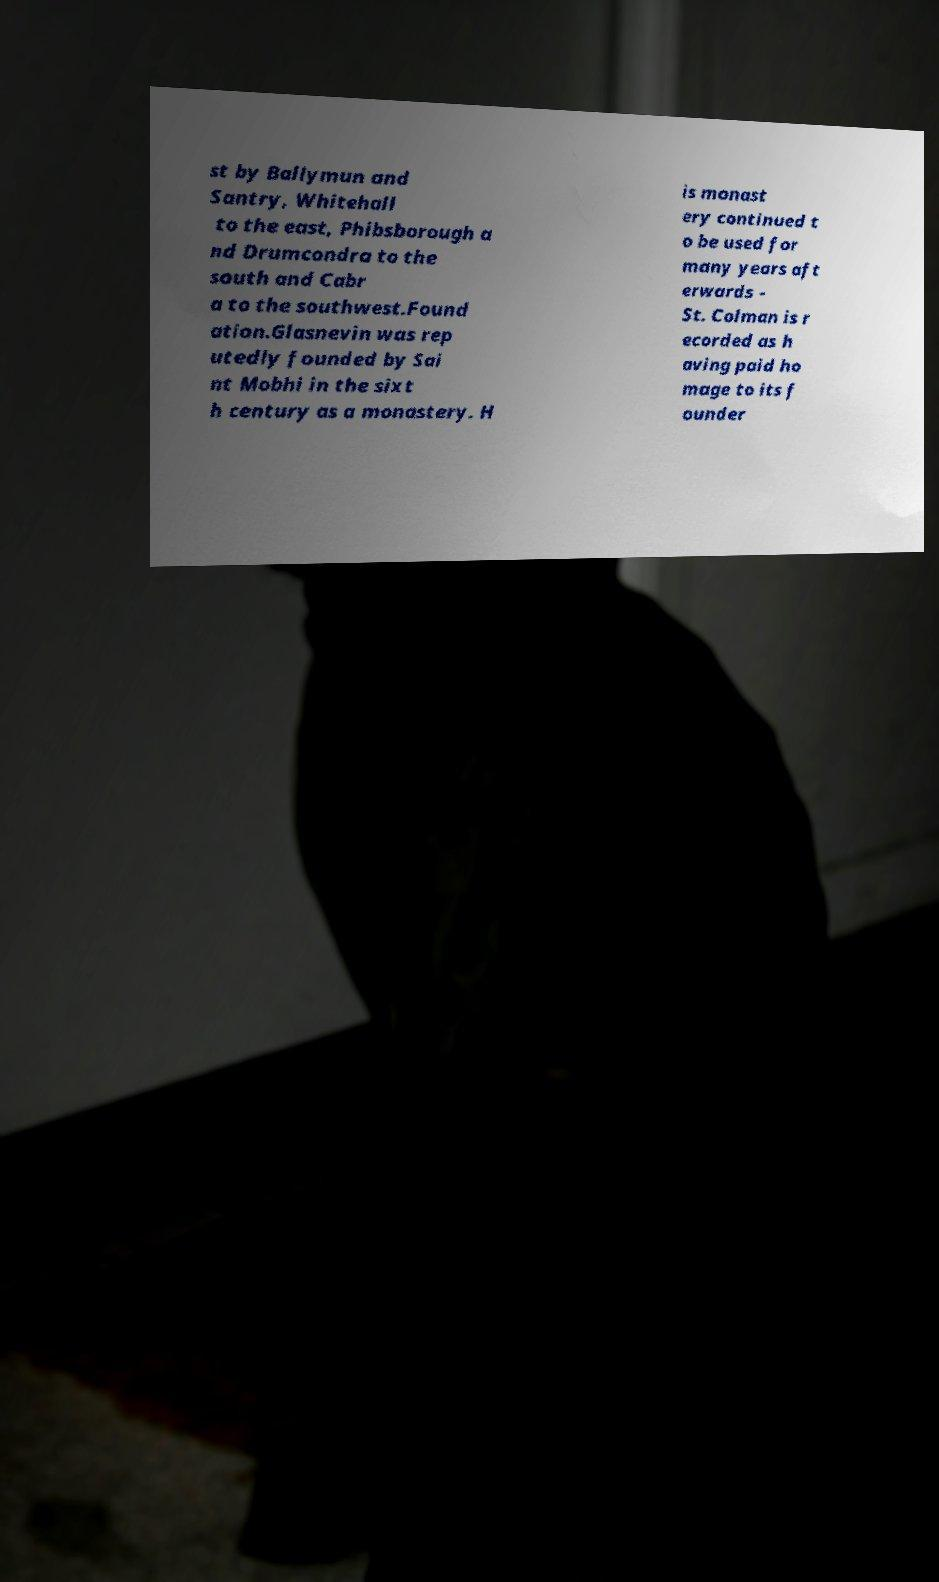For documentation purposes, I need the text within this image transcribed. Could you provide that? st by Ballymun and Santry, Whitehall to the east, Phibsborough a nd Drumcondra to the south and Cabr a to the southwest.Found ation.Glasnevin was rep utedly founded by Sai nt Mobhi in the sixt h century as a monastery. H is monast ery continued t o be used for many years aft erwards - St. Colman is r ecorded as h aving paid ho mage to its f ounder 